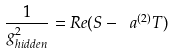Convert formula to latex. <formula><loc_0><loc_0><loc_500><loc_500>\frac { 1 } { g ^ { 2 } _ { h i d d e n } } = R e ( S - \ a ^ { ( 2 ) } T )</formula> 